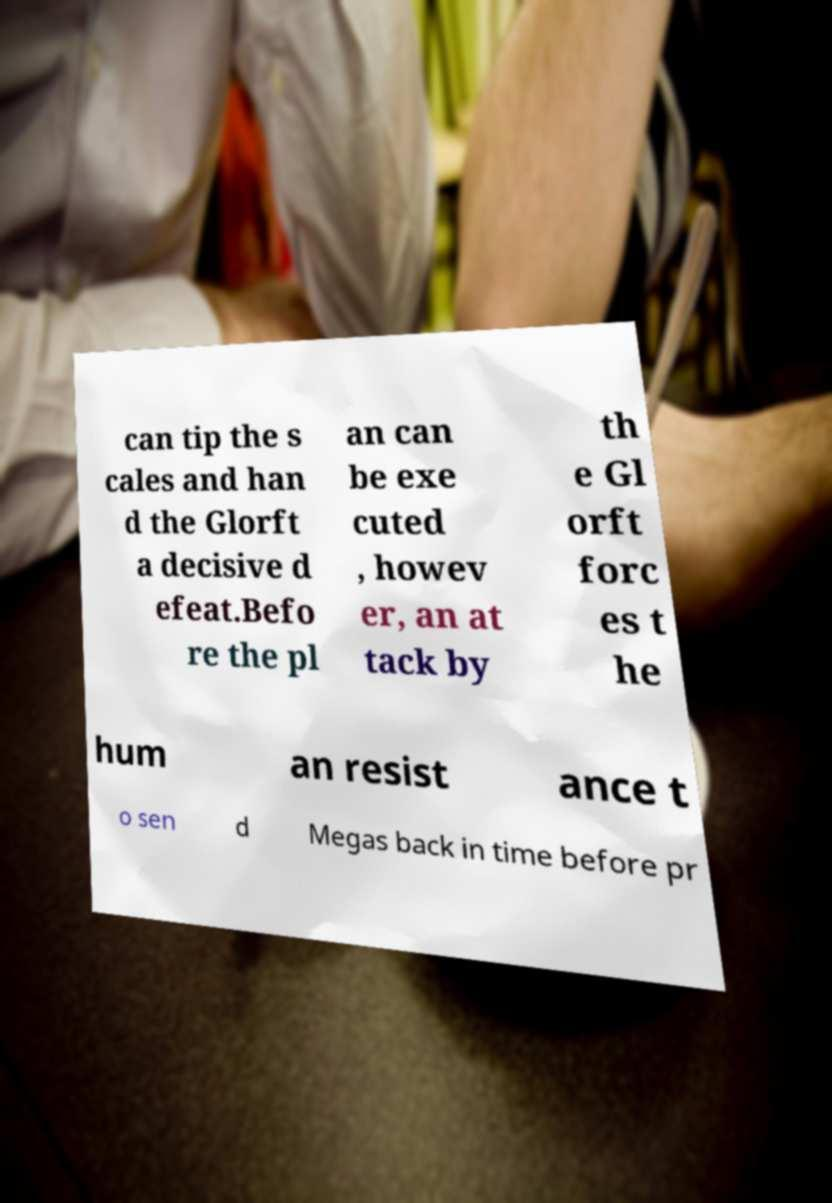For documentation purposes, I need the text within this image transcribed. Could you provide that? can tip the s cales and han d the Glorft a decisive d efeat.Befo re the pl an can be exe cuted , howev er, an at tack by th e Gl orft forc es t he hum an resist ance t o sen d Megas back in time before pr 